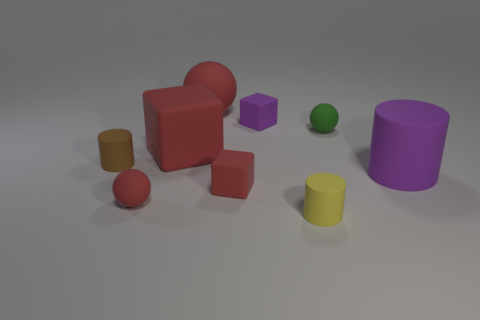Subtract 1 balls. How many balls are left? 2 Add 1 small matte cylinders. How many objects exist? 10 Subtract all blocks. How many objects are left? 6 Subtract 1 purple blocks. How many objects are left? 8 Subtract all small purple matte cylinders. Subtract all tiny brown objects. How many objects are left? 8 Add 5 large purple matte cylinders. How many large purple matte cylinders are left? 6 Add 3 purple matte blocks. How many purple matte blocks exist? 4 